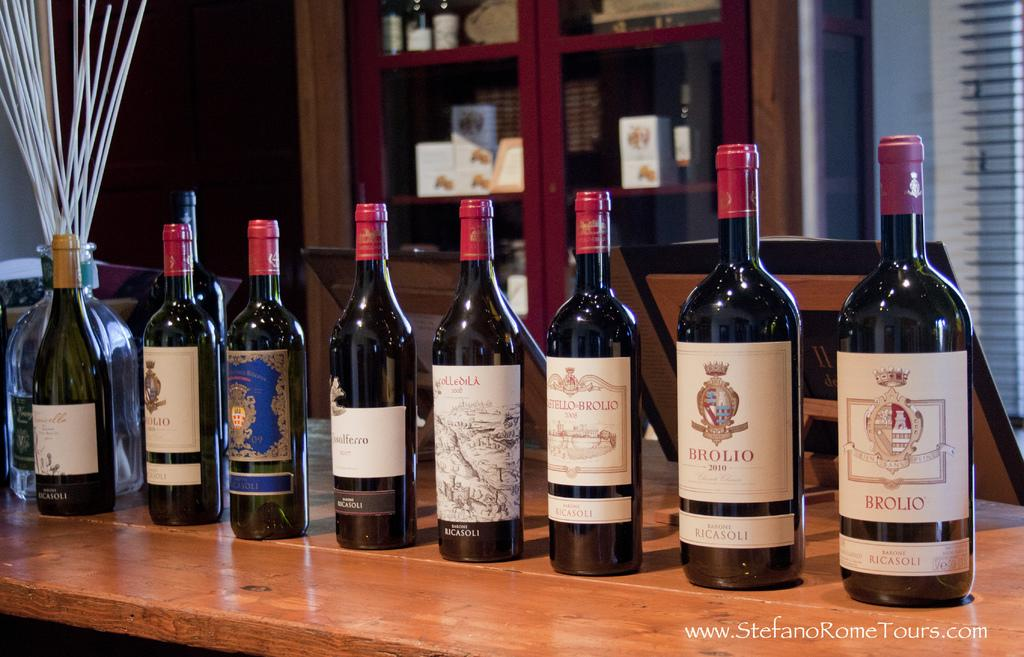<image>
Offer a succinct explanation of the picture presented. Bottle on the right that says the word BROLIO on the label. 